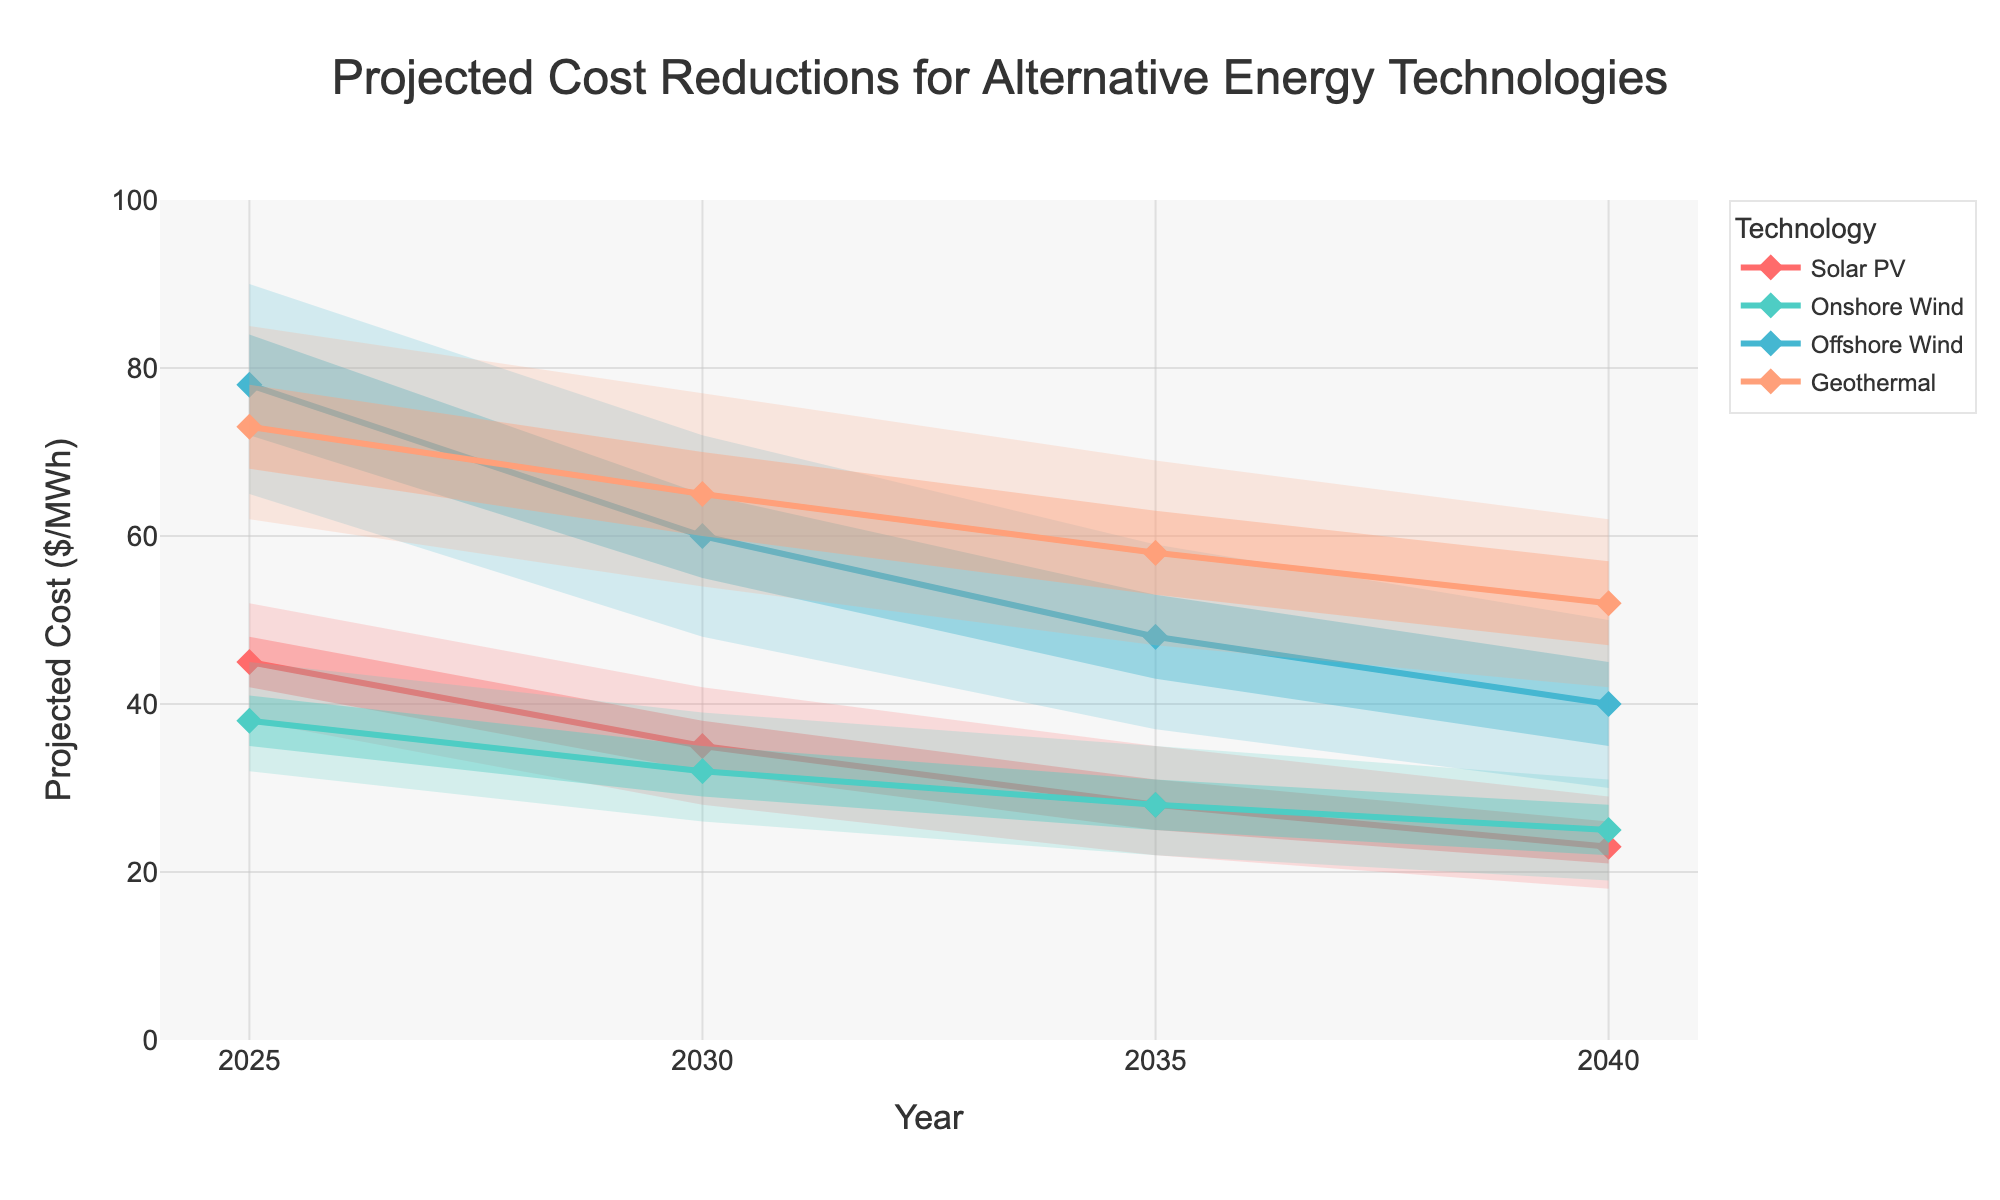What is the title of the chart? The title of the chart is usually displayed at the top. In this case, it is "Projected Cost Reductions for Alternative Energy Technologies".
Answer: Projected Cost Reductions for Alternative Energy Technologies What is the projected cost of Solar PV in 2030? Locate Solar PV on the legend and trace its line to the year 2030. The projected cost is marked at the corresponding point on the y-axis.
Answer: $35/MWh Which technology is projected to have the highest cost in 2040? Compare the projected costs of all technologies in the year 2040 by looking at their respective projections on that year's vertical line.
Answer: Offshore Wind How much is the expected cost reduction for Onshore Wind from 2025 to 2040? Subtract the projected cost of Onshore Wind in 2040 from its projected cost in 2025: 38 - 25 = 13.
Answer: $13/MWh By how much is the lower 95% confidence interval of Geothermal expected to decrease between 2025 and 2040? Identify the lower 95% CI for Geothermal in 2025 and 2040, then subtract the latter from the former: 62 - 42 = 20.
Answer: $20/MWh What is the range of projected costs for Offshore Wind in 2035 within the 75% confidence interval? For Offshore Wind in 2035, the lower 75% CI is 43 and the upper 75% CI is 53. Subtract the lower bound from the upper bound: 53 - 43 = 10.
Answer: $10/MWh Which technology shows the largest projected cost reduction from 2025 to 2040? Calculate the projected cost reductions for all technologies. The one with the largest difference will be the answer. Solar PV: 45 - 23 = 22. Onshore Wind: 38 - 25 = 13. Offshore Wind: 78 - 40 = 38. Geothermal: 73 - 52 = 21.
Answer: Offshore Wind How does the confidence interval width for Solar PV in 2025 compare to that in 2040? Calculate the difference between the upper and lower 95% CI for Solar PV in 2025 and in 2040, then compare the widths: 52 - 38 = 14 for 2025, and 29 - 18 = 11 for 2040.
Answer: Reduced by 3/MWh 